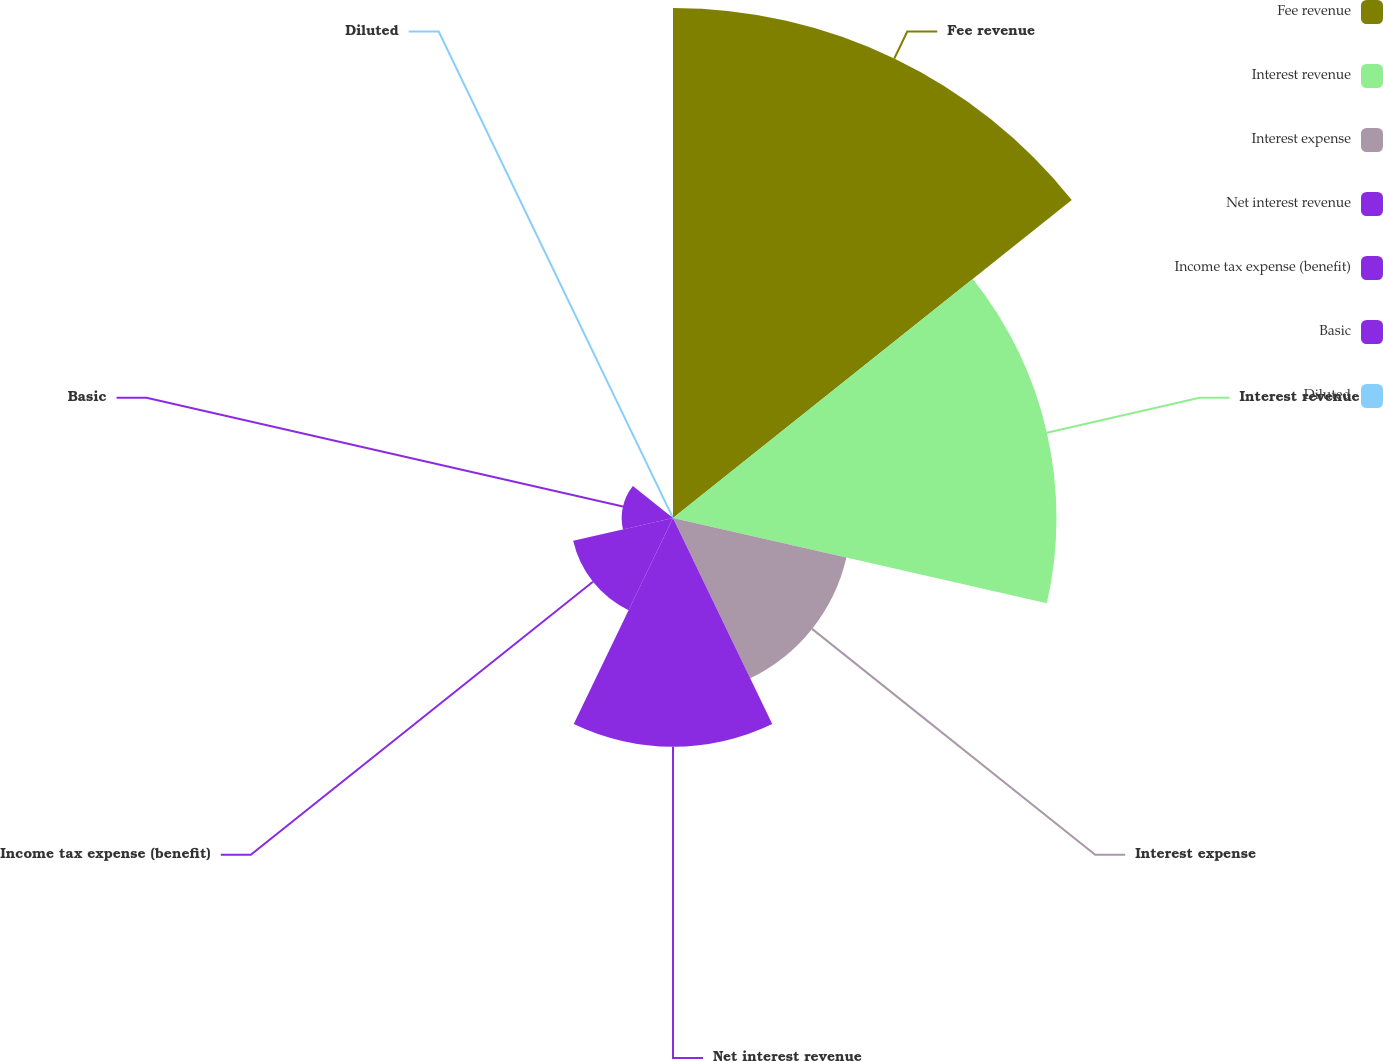Convert chart to OTSL. <chart><loc_0><loc_0><loc_500><loc_500><pie_chart><fcel>Fee revenue<fcel>Interest revenue<fcel>Interest expense<fcel>Net interest revenue<fcel>Income tax expense (benefit)<fcel>Basic<fcel>Diluted<nl><fcel>35.07%<fcel>26.37%<fcel>12.23%<fcel>15.73%<fcel>7.04%<fcel>3.53%<fcel>0.03%<nl></chart> 